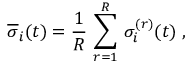<formula> <loc_0><loc_0><loc_500><loc_500>\overline { \sigma } _ { i } ( t ) = \frac { 1 } { R } \, \sum _ { r = 1 } ^ { R } \, \sigma _ { i } ^ { ( r ) } ( t ) \, ,</formula> 